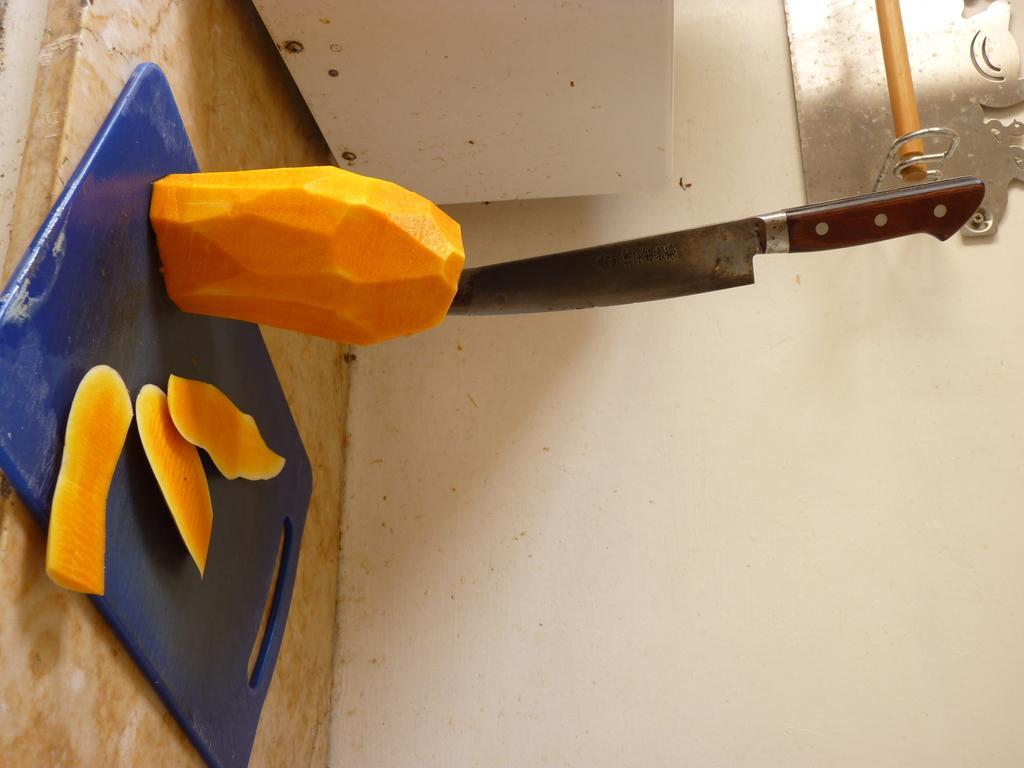In one or two sentences, can you explain what this image depicts? In the picture there is a table, on the table there is a chopping board, on the board there is a fruit and there are some slices, there is a knife present on the fruit, beside there is a wall, on the wall there is a metal plate and a wooden pole. 